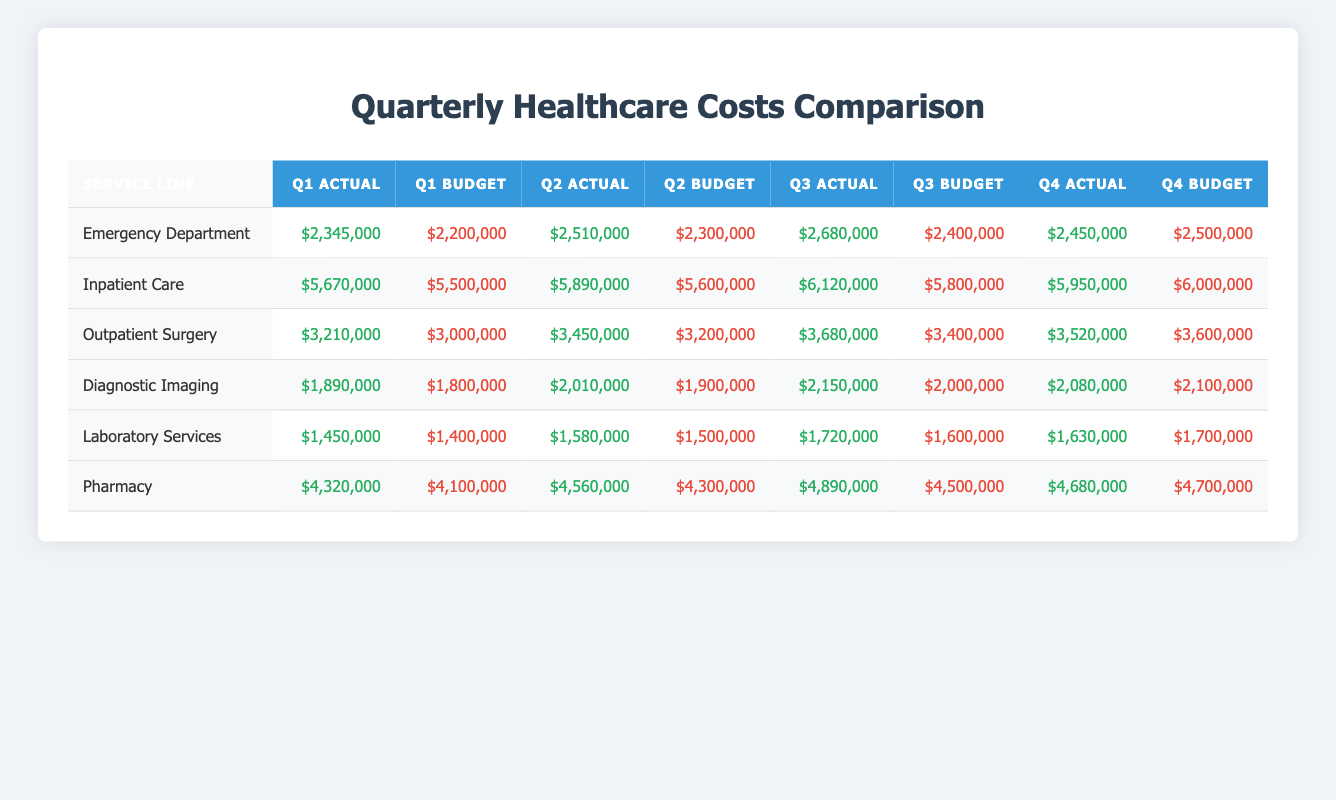What is the actual cost for the Outpatient Surgery in Q3? The table lists the actual costs for each service line by quarter. For Outpatient Surgery in Q3, the actual cost is provided directly, which is $3,680,000.
Answer: $3,680,000 Did the Inpatient Care actual costs exceed the budget in every quarter? To answer this, we need to compare the actual costs with the budgeted amounts for each quarter: Q1 Actual $5,670,000 > Q1 Budget $5,500,000 (yes), Q2 Actual $5,890,000 > Q2 Budget $5,600,000 (yes), Q3 Actual $6,120,000 > Q3 Budget $5,800,000 (yes), Q4 Actual $5,950,000 < Q4 Budget $6,000,000 (no). Since it did not exceed the budget in Q4, the answer is no.
Answer: No What is the total of actual costs for the Emergency Department across all four quarters? To find the total actual costs for the Emergency Department, we add the actual costs from all quarters: Q1 $2,345,000 + Q2 $2,510,000 + Q3 $2,680,000 + Q4 $2,450,000 = $10,985,000.
Answer: $10,985,000 Is the average actual cost for Laboratory Services in the first half of the year greater than $1,500,000? The actual costs for Laboratory Services in the first half (Q1 and Q2) are $1,450,000 and $1,580,000. We calculate the average as: ($1,450,000 + $1,580,000) / 2 = $1,515,000. Since $1,515,000 is less than $1,500,000, the answer is no.
Answer: Yes Which service line had the highest Q2 actual costs, and what was the amount? We need to compare the Q2 actual costs across all service lines: Emergency Department $2,510,000, Inpatient Care $5,890,000, Outpatient Surgery $3,450,000, Diagnostic Imaging $2,010,000, Laboratory Services $1,580,000, and Pharmacy $4,560,000. The highest is Inpatient Care at $5,890,000.
Answer: Inpatient Care, $5,890,000 How much more did the actual costs for Pharmacy in Q3 exceed the budget compared to Q1? The actual costs for Pharmacy in Q3 is $4,890,000 and the budget is $4,500,000. The difference is $4,890,000 - $4,500,000 = $390,000. In Q1, the actual is $4,320,000 and the budget is $4,100,000, leading to a difference of $4,320,000 - $4,100,000 = $220,000. Finally, we compare those differences: $390,000 - $220,000 = $170,000 more in Q3.
Answer: $170,000 Was there a quarter where the actual costs for the Diagnostic Imaging were less than the budgeted costs? We compare each quarter: Q1 Actual $1,890,000 vs. Budget $1,800,000 (more), Q2 Actual $2,010,000 vs. Budget $1,900,000 (more), Q3 Actual $2,150,000 vs. Budget $2,000,000 (more), Q4 Actual $2,080,000 vs. Budget $2,100,000 (less). Since Q4 has lower actual costs, the answer is yes.
Answer: Yes What is the difference between the total actual costs for Inpatient Care and Pharmacy in Q4? For Q4, Inpatient Care actual cost is $5,950,000 and Pharmacy is $4,680,000. The difference is $5,950,000 - $4,680,000 = $1,270,000.
Answer: $1,270,000 